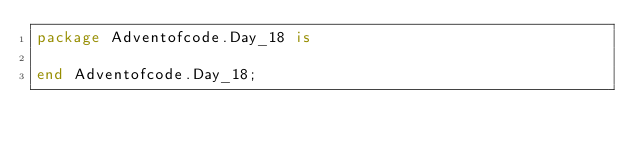<code> <loc_0><loc_0><loc_500><loc_500><_Ada_>package Adventofcode.Day_18 is

end Adventofcode.Day_18;
</code> 